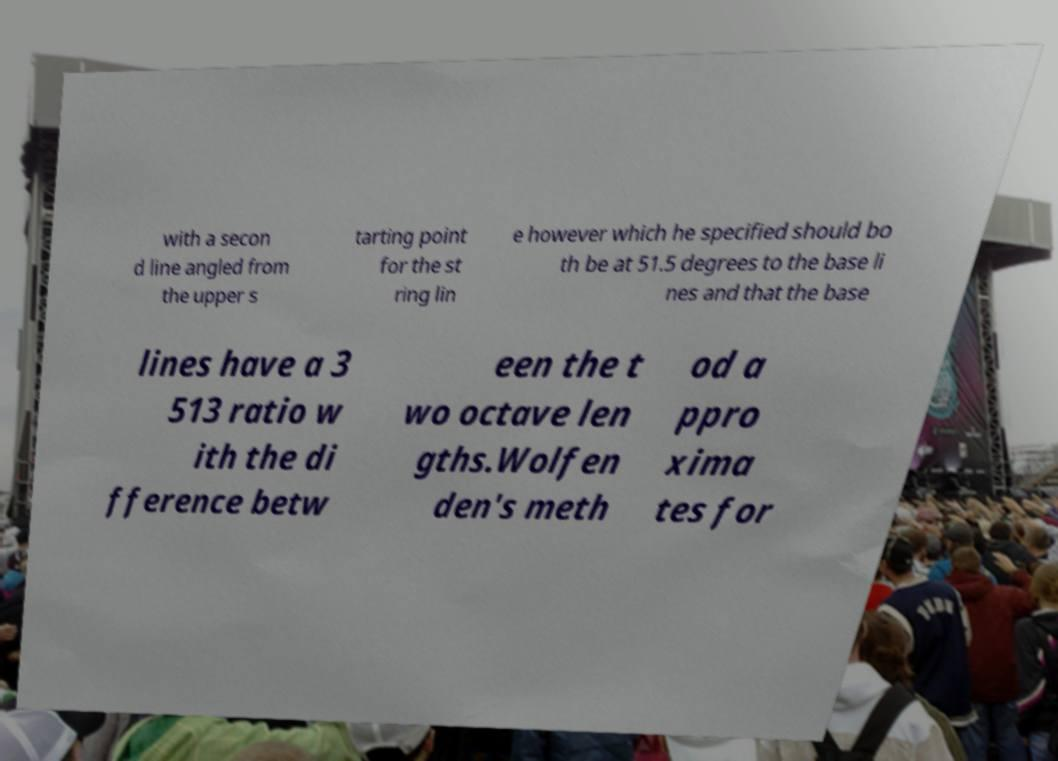Please read and relay the text visible in this image. What does it say? with a secon d line angled from the upper s tarting point for the st ring lin e however which he specified should bo th be at 51.5 degrees to the base li nes and that the base lines have a 3 513 ratio w ith the di fference betw een the t wo octave len gths.Wolfen den's meth od a ppro xima tes for 